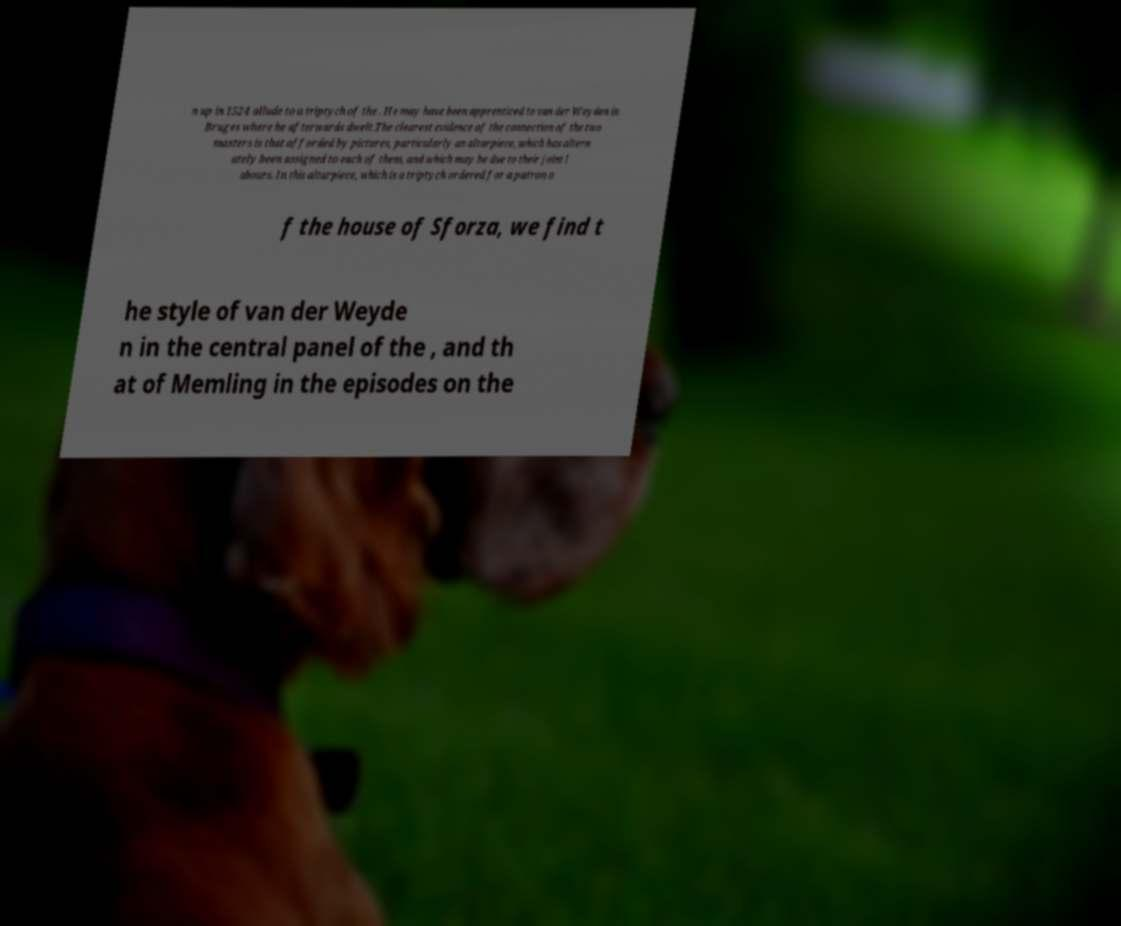Can you accurately transcribe the text from the provided image for me? n up in 1524 allude to a triptych of the . He may have been apprenticed to van der Weyden in Bruges where he afterwards dwelt.The clearest evidence of the connection of the two masters is that afforded by pictures, particularly an altarpiece, which has altern ately been assigned to each of them, and which may be due to their joint l abours. In this altarpiece, which is a triptych ordered for a patron o f the house of Sforza, we find t he style of van der Weyde n in the central panel of the , and th at of Memling in the episodes on the 